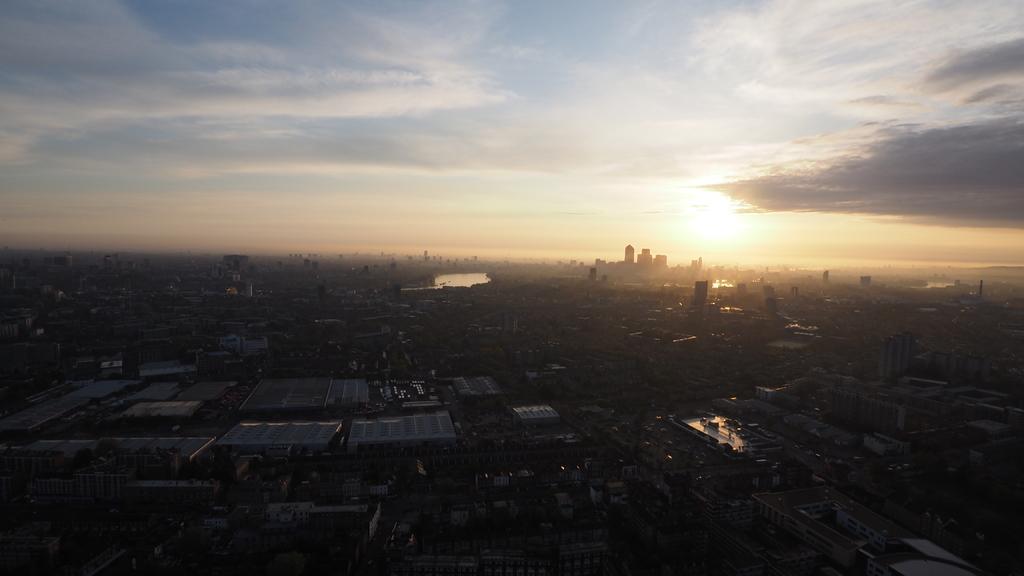In one or two sentences, can you explain what this image depicts? As we can see in the image there are buildings, water, sky and clouds. 